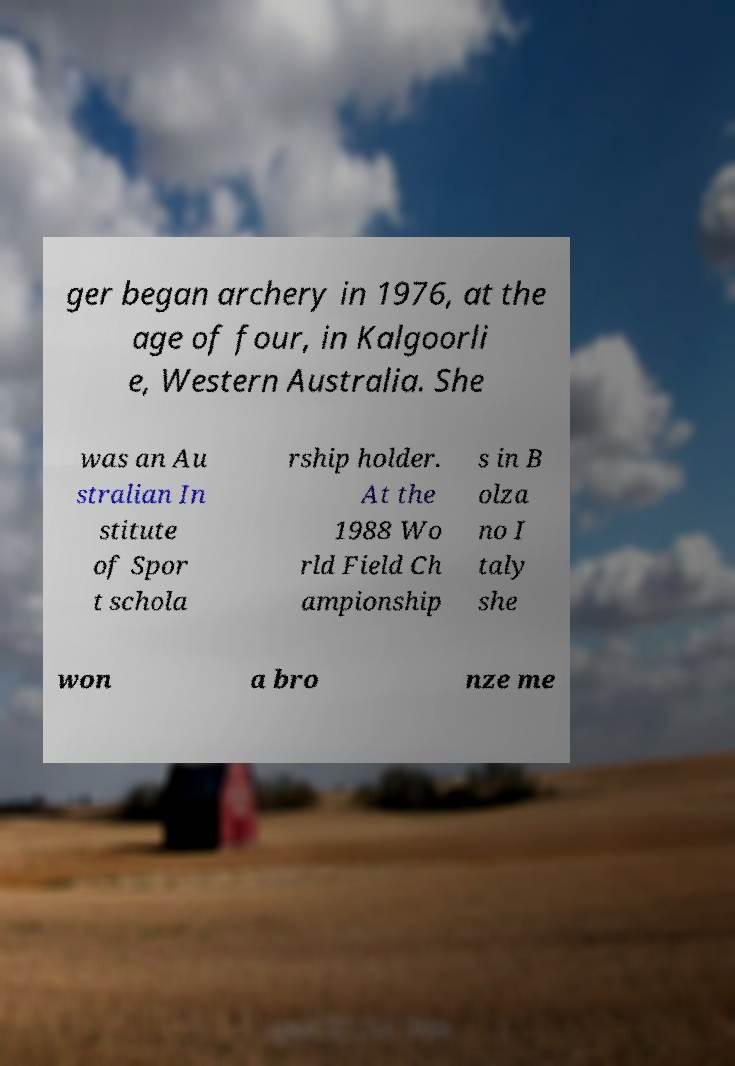Could you extract and type out the text from this image? ger began archery in 1976, at the age of four, in Kalgoorli e, Western Australia. She was an Au stralian In stitute of Spor t schola rship holder. At the 1988 Wo rld Field Ch ampionship s in B olza no I taly she won a bro nze me 